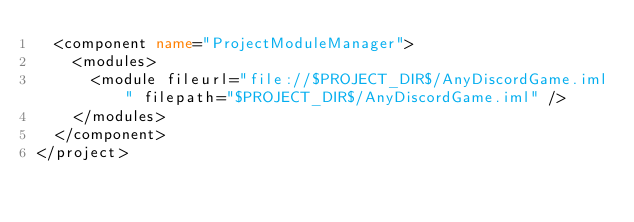<code> <loc_0><loc_0><loc_500><loc_500><_XML_>  <component name="ProjectModuleManager">
    <modules>
      <module fileurl="file://$PROJECT_DIR$/AnyDiscordGame.iml" filepath="$PROJECT_DIR$/AnyDiscordGame.iml" />
    </modules>
  </component>
</project></code> 